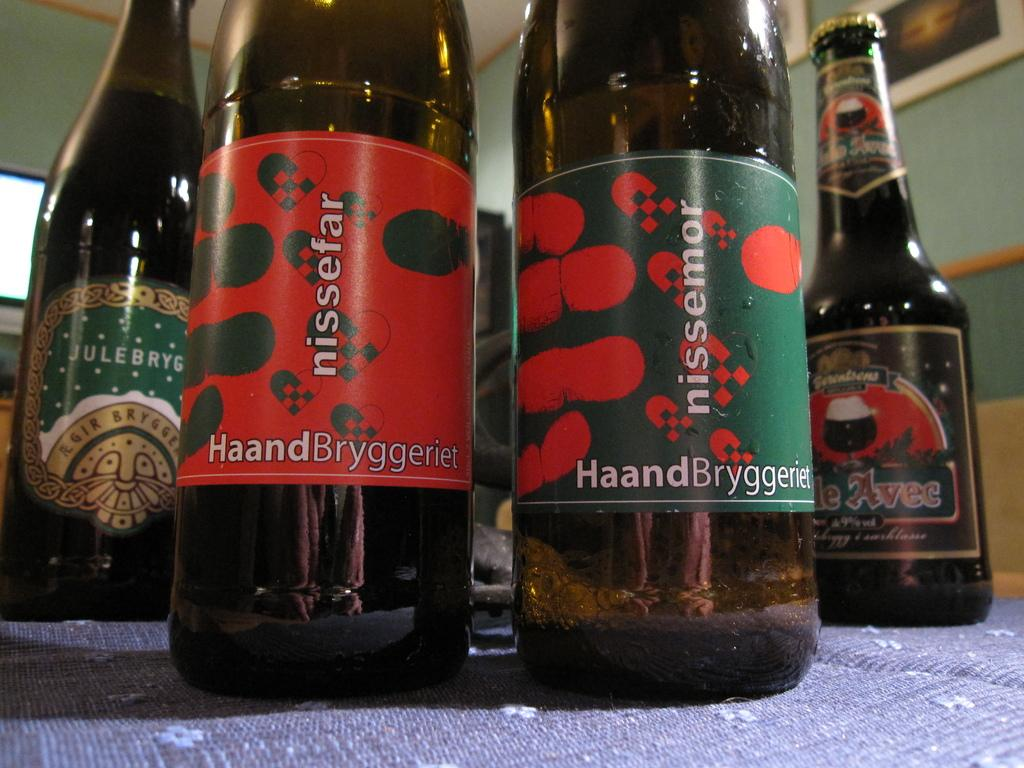<image>
Create a compact narrative representing the image presented. Four beer bottles sit on a blue tablecloth, two of the bottles are labeled as Nissefar. 